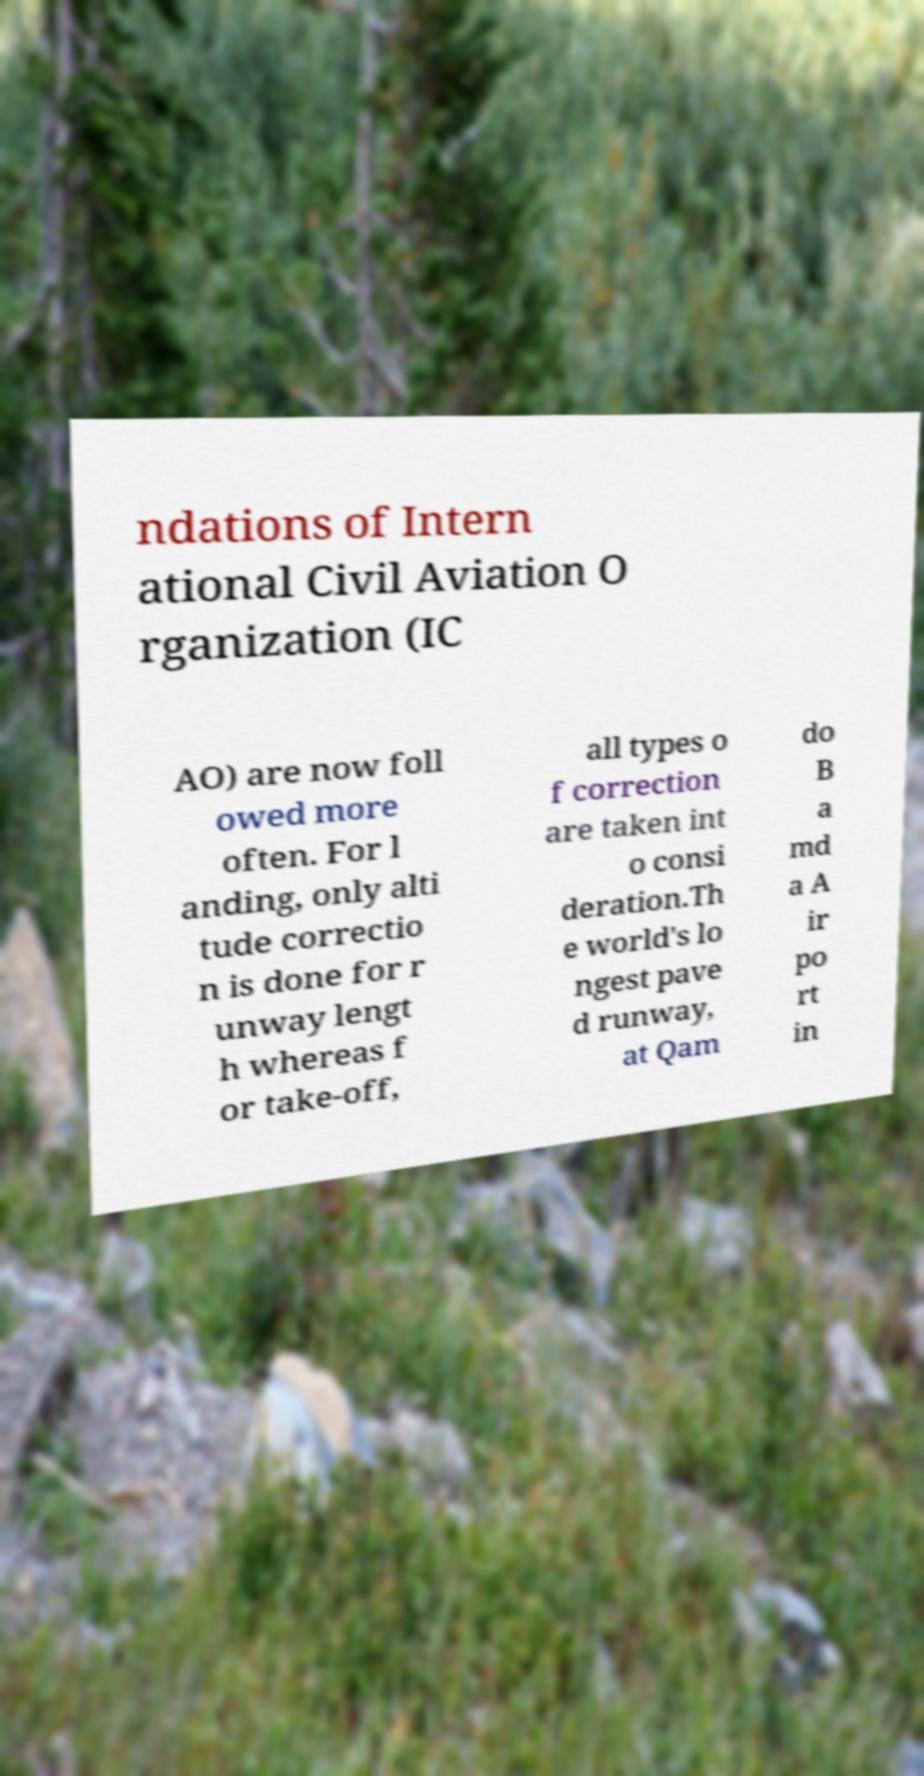Can you accurately transcribe the text from the provided image for me? ndations of Intern ational Civil Aviation O rganization (IC AO) are now foll owed more often. For l anding, only alti tude correctio n is done for r unway lengt h whereas f or take-off, all types o f correction are taken int o consi deration.Th e world's lo ngest pave d runway, at Qam do B a md a A ir po rt in 